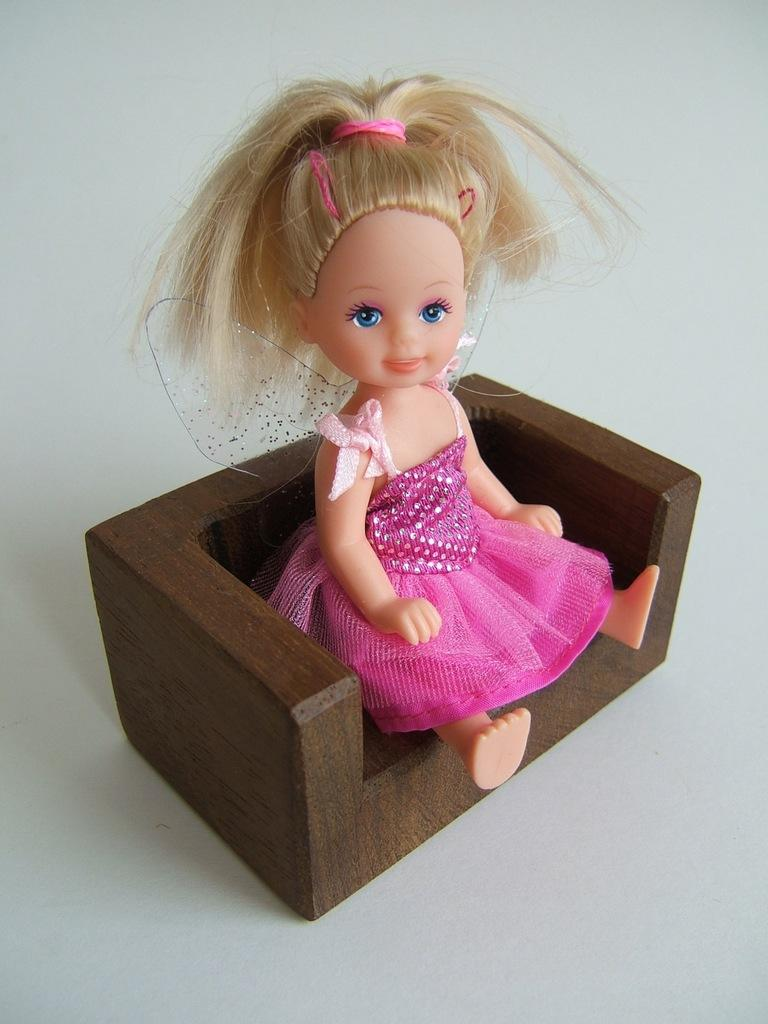What object in the image is not a typical piece of furniture or decoration? There is a toy in the image. Where is the toy located in the image? The toy is sitting on a chair. What type of yam is growing in the garden in the image? There is no garden or yam present in the image; it only features a toy sitting on a chair. 